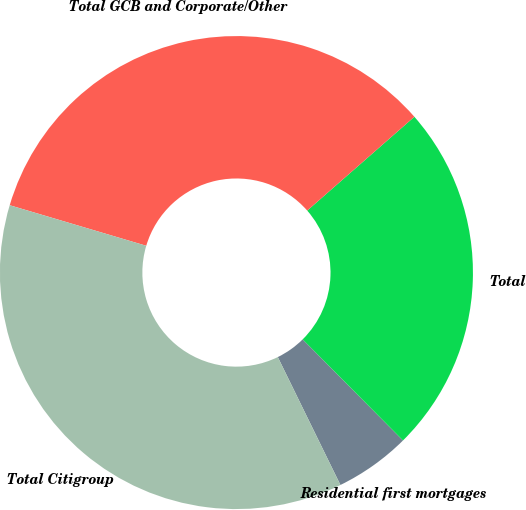Convert chart. <chart><loc_0><loc_0><loc_500><loc_500><pie_chart><fcel>Residential first mortgages<fcel>Total<fcel>Total GCB and Corporate/Other<fcel>Total Citigroup<nl><fcel>5.19%<fcel>24.01%<fcel>33.96%<fcel>36.84%<nl></chart> 